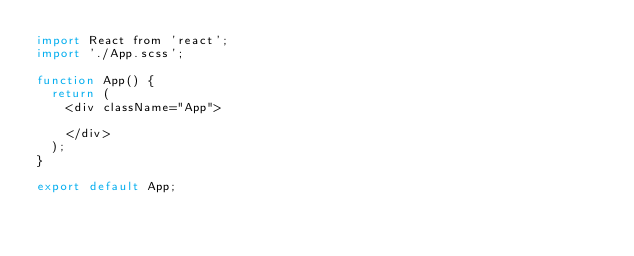<code> <loc_0><loc_0><loc_500><loc_500><_JavaScript_>import React from 'react';
import './App.scss';

function App() {
  return (
    <div className="App">
     
    </div>
  );
}

export default App;
</code> 